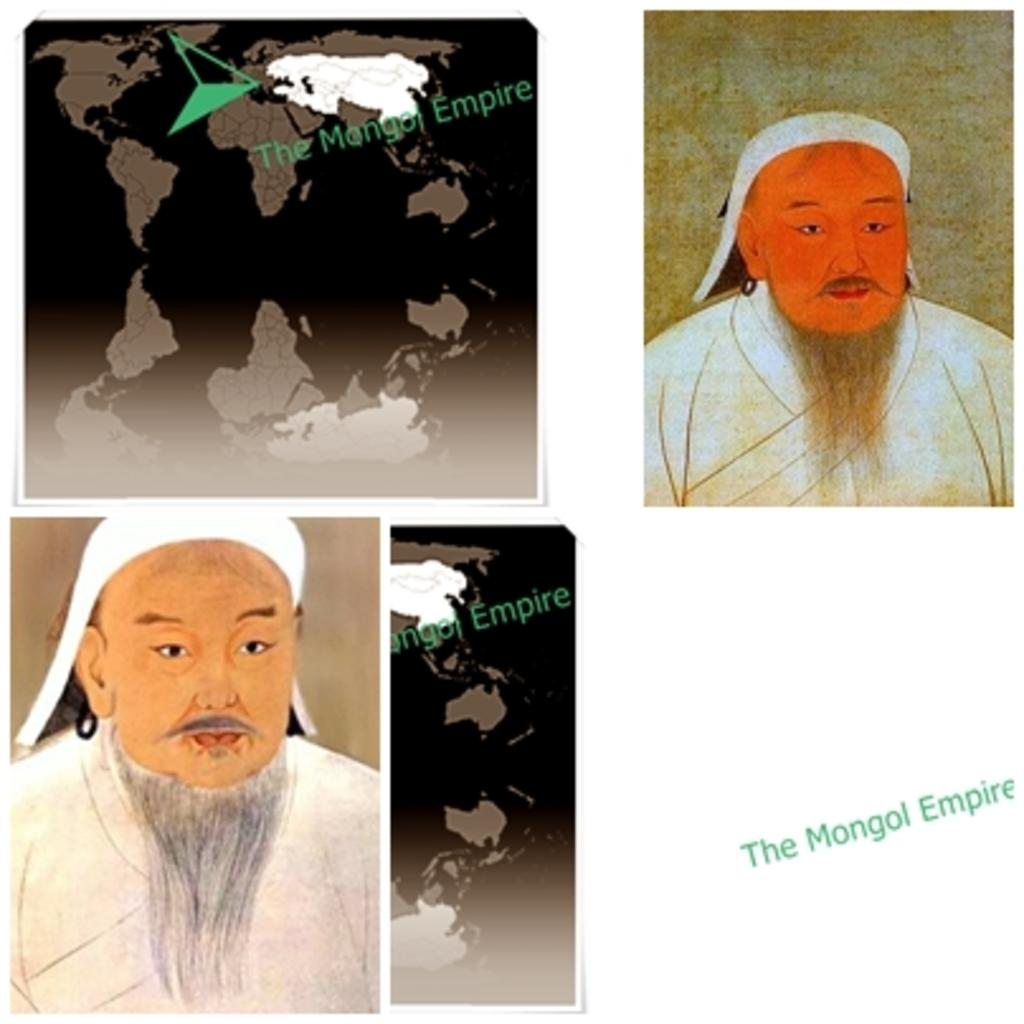What type of content is present in the image? The image contains texts. What geographical representations can be seen in the image? There are two maps in the image. What type of artwork is featured in the image? There are two paintings of a person in the image. What is the color of the background in the image? The background of the image is white in color. What type of poisonous substance can be seen in the image? There is no poisonous substance present in the image. What type of field is visible in the image? There is no field visible in the image; it contains texts, maps, and paintings. 